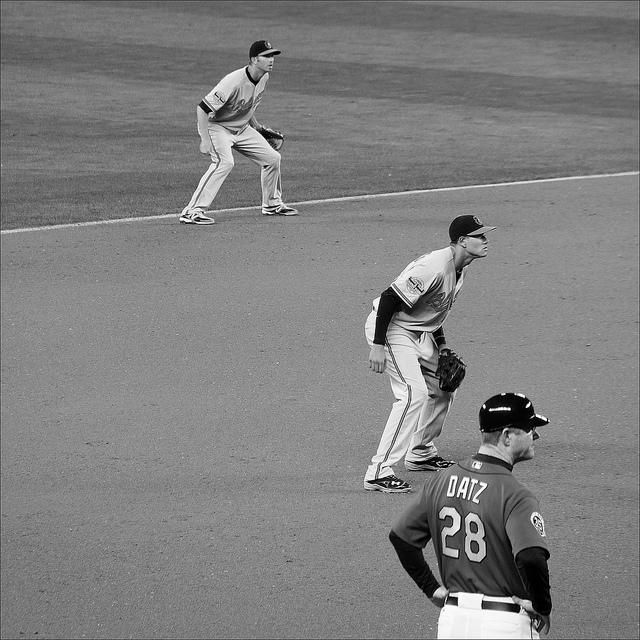What is the man in front's last name?
Quick response, please. Datz. Is this an old photo?
Answer briefly. No. What is the man wearing?
Be succinct. Uniform. Are the men wearing gloves right handed?
Concise answer only. Yes. 